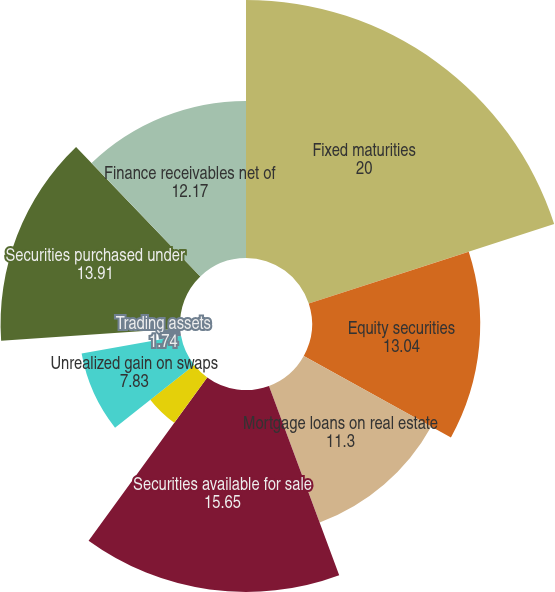Convert chart to OTSL. <chart><loc_0><loc_0><loc_500><loc_500><pie_chart><fcel>Fixed maturities<fcel>Equity securities<fcel>Mortgage loans on real estate<fcel>Securities available for sale<fcel>Trading securities<fcel>Spot commodities<fcel>Unrealized gain on swaps<fcel>Trading assets<fcel>Securities purchased under<fcel>Finance receivables net of<nl><fcel>20.0%<fcel>13.04%<fcel>11.3%<fcel>15.65%<fcel>4.35%<fcel>0.0%<fcel>7.83%<fcel>1.74%<fcel>13.91%<fcel>12.17%<nl></chart> 